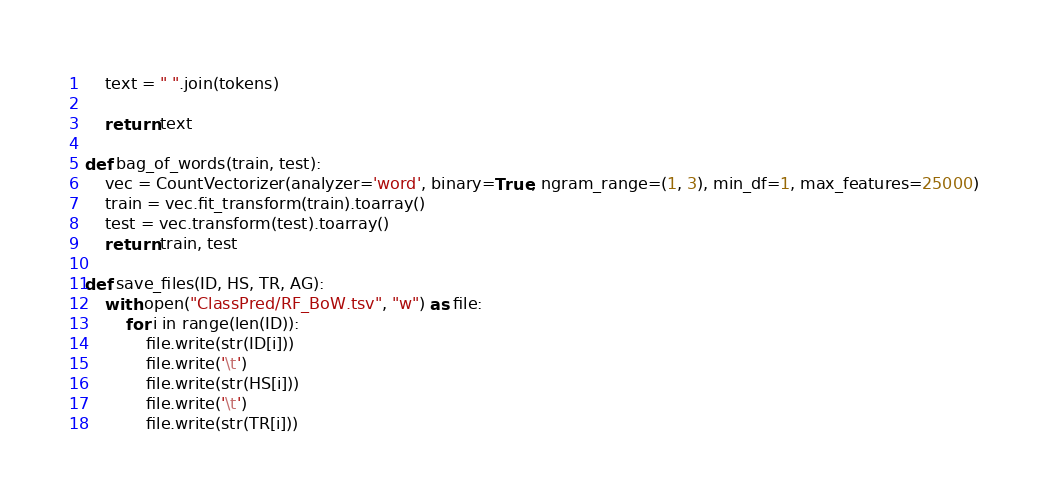Convert code to text. <code><loc_0><loc_0><loc_500><loc_500><_Python_>
    text = " ".join(tokens)

    return text

def bag_of_words(train, test):
    vec = CountVectorizer(analyzer='word', binary=True, ngram_range=(1, 3), min_df=1, max_features=25000)
    train = vec.fit_transform(train).toarray()
    test = vec.transform(test).toarray()
    return train, test

def save_files(ID, HS, TR, AG):
    with open("ClassPred/RF_BoW.tsv", "w") as file:
        for i in range(len(ID)):
            file.write(str(ID[i]))
            file.write('\t')
            file.write(str(HS[i]))
            file.write('\t')
            file.write(str(TR[i]))</code> 